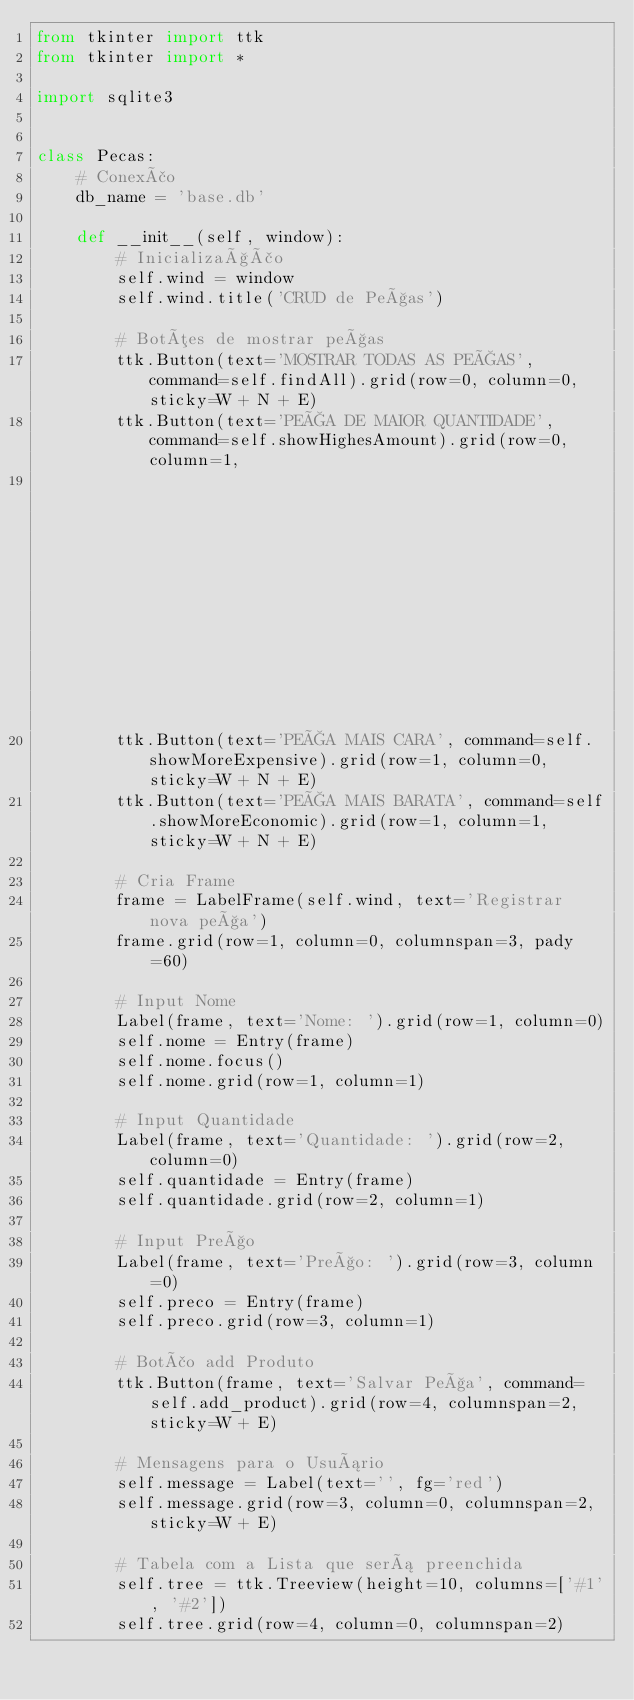<code> <loc_0><loc_0><loc_500><loc_500><_Python_>from tkinter import ttk
from tkinter import *

import sqlite3


class Pecas:
    # Conexão
    db_name = 'base.db'

    def __init__(self, window):
        # Inicialização
        self.wind = window
        self.wind.title('CRUD de Peças')

        # Botões de mostrar peças
        ttk.Button(text='MOSTRAR TODAS AS PEÇAS', command=self.findAll).grid(row=0, column=0, sticky=W + N + E)
        ttk.Button(text='PEÇA DE MAIOR QUANTIDADE', command=self.showHighesAmount).grid(row=0, column=1,
                                                                                        sticky=W + N + E)
        ttk.Button(text='PEÇA MAIS CARA', command=self.showMoreExpensive).grid(row=1, column=0, sticky=W + N + E)
        ttk.Button(text='PEÇA MAIS BARATA', command=self.showMoreEconomic).grid(row=1, column=1, sticky=W + N + E)

        # Cria Frame
        frame = LabelFrame(self.wind, text='Registrar nova peça')
        frame.grid(row=1, column=0, columnspan=3, pady=60)

        # Input Nome
        Label(frame, text='Nome: ').grid(row=1, column=0)
        self.nome = Entry(frame)
        self.nome.focus()
        self.nome.grid(row=1, column=1)

        # Input Quantidade
        Label(frame, text='Quantidade: ').grid(row=2, column=0)
        self.quantidade = Entry(frame)
        self.quantidade.grid(row=2, column=1)

        # Input Preço
        Label(frame, text='Preço: ').grid(row=3, column=0)
        self.preco = Entry(frame)
        self.preco.grid(row=3, column=1)

        # Botão add Produto
        ttk.Button(frame, text='Salvar Peça', command=self.add_product).grid(row=4, columnspan=2, sticky=W + E)

        # Mensagens para o Usuário
        self.message = Label(text='', fg='red')
        self.message.grid(row=3, column=0, columnspan=2, sticky=W + E)

        # Tabela com a Lista que será preenchida
        self.tree = ttk.Treeview(height=10, columns=['#1', '#2'])
        self.tree.grid(row=4, column=0, columnspan=2)</code> 